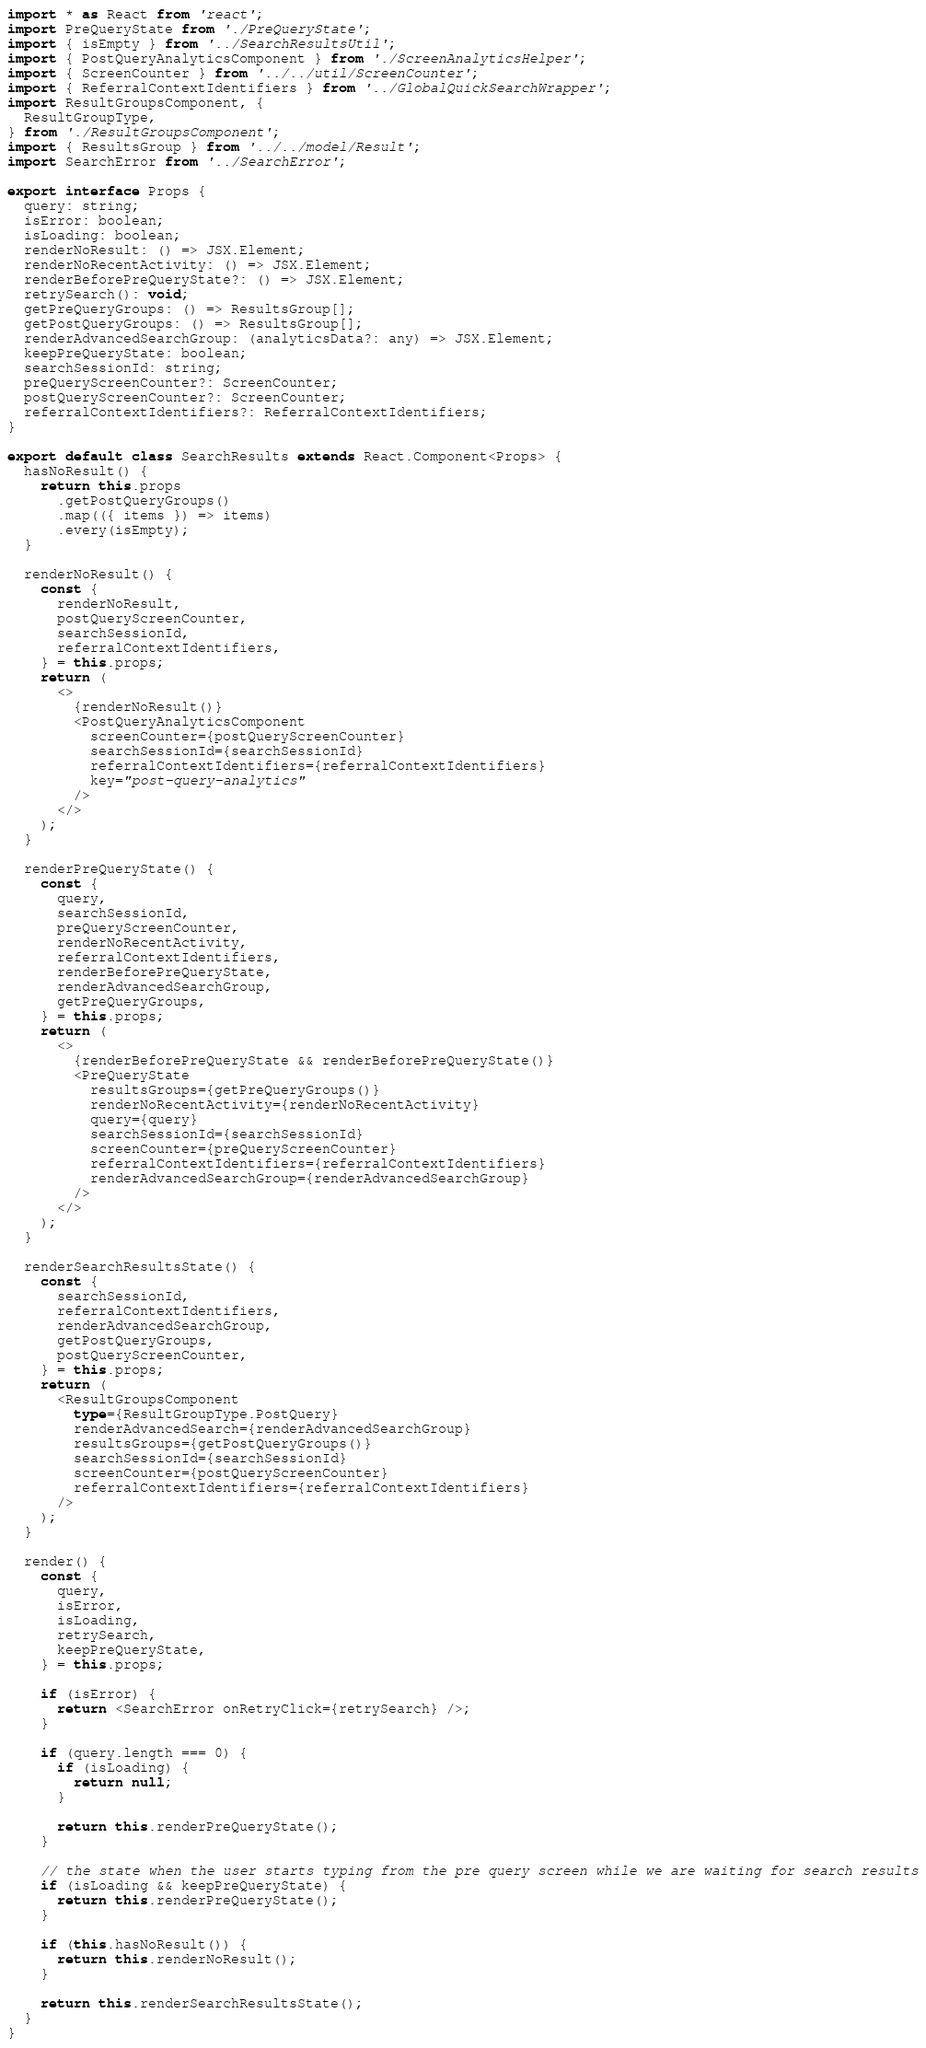Convert code to text. <code><loc_0><loc_0><loc_500><loc_500><_TypeScript_>import * as React from 'react';
import PreQueryState from './PreQueryState';
import { isEmpty } from '../SearchResultsUtil';
import { PostQueryAnalyticsComponent } from './ScreenAnalyticsHelper';
import { ScreenCounter } from '../../util/ScreenCounter';
import { ReferralContextIdentifiers } from '../GlobalQuickSearchWrapper';
import ResultGroupsComponent, {
  ResultGroupType,
} from './ResultGroupsComponent';
import { ResultsGroup } from '../../model/Result';
import SearchError from '../SearchError';

export interface Props {
  query: string;
  isError: boolean;
  isLoading: boolean;
  renderNoResult: () => JSX.Element;
  renderNoRecentActivity: () => JSX.Element;
  renderBeforePreQueryState?: () => JSX.Element;
  retrySearch(): void;
  getPreQueryGroups: () => ResultsGroup[];
  getPostQueryGroups: () => ResultsGroup[];
  renderAdvancedSearchGroup: (analyticsData?: any) => JSX.Element;
  keepPreQueryState: boolean;
  searchSessionId: string;
  preQueryScreenCounter?: ScreenCounter;
  postQueryScreenCounter?: ScreenCounter;
  referralContextIdentifiers?: ReferralContextIdentifiers;
}

export default class SearchResults extends React.Component<Props> {
  hasNoResult() {
    return this.props
      .getPostQueryGroups()
      .map(({ items }) => items)
      .every(isEmpty);
  }

  renderNoResult() {
    const {
      renderNoResult,
      postQueryScreenCounter,
      searchSessionId,
      referralContextIdentifiers,
    } = this.props;
    return (
      <>
        {renderNoResult()}
        <PostQueryAnalyticsComponent
          screenCounter={postQueryScreenCounter}
          searchSessionId={searchSessionId}
          referralContextIdentifiers={referralContextIdentifiers}
          key="post-query-analytics"
        />
      </>
    );
  }

  renderPreQueryState() {
    const {
      query,
      searchSessionId,
      preQueryScreenCounter,
      renderNoRecentActivity,
      referralContextIdentifiers,
      renderBeforePreQueryState,
      renderAdvancedSearchGroup,
      getPreQueryGroups,
    } = this.props;
    return (
      <>
        {renderBeforePreQueryState && renderBeforePreQueryState()}
        <PreQueryState
          resultsGroups={getPreQueryGroups()}
          renderNoRecentActivity={renderNoRecentActivity}
          query={query}
          searchSessionId={searchSessionId}
          screenCounter={preQueryScreenCounter}
          referralContextIdentifiers={referralContextIdentifiers}
          renderAdvancedSearchGroup={renderAdvancedSearchGroup}
        />
      </>
    );
  }

  renderSearchResultsState() {
    const {
      searchSessionId,
      referralContextIdentifiers,
      renderAdvancedSearchGroup,
      getPostQueryGroups,
      postQueryScreenCounter,
    } = this.props;
    return (
      <ResultGroupsComponent
        type={ResultGroupType.PostQuery}
        renderAdvancedSearch={renderAdvancedSearchGroup}
        resultsGroups={getPostQueryGroups()}
        searchSessionId={searchSessionId}
        screenCounter={postQueryScreenCounter}
        referralContextIdentifiers={referralContextIdentifiers}
      />
    );
  }

  render() {
    const {
      query,
      isError,
      isLoading,
      retrySearch,
      keepPreQueryState,
    } = this.props;

    if (isError) {
      return <SearchError onRetryClick={retrySearch} />;
    }

    if (query.length === 0) {
      if (isLoading) {
        return null;
      }

      return this.renderPreQueryState();
    }

    // the state when the user starts typing from the pre query screen while we are waiting for search results
    if (isLoading && keepPreQueryState) {
      return this.renderPreQueryState();
    }

    if (this.hasNoResult()) {
      return this.renderNoResult();
    }

    return this.renderSearchResultsState();
  }
}
</code> 